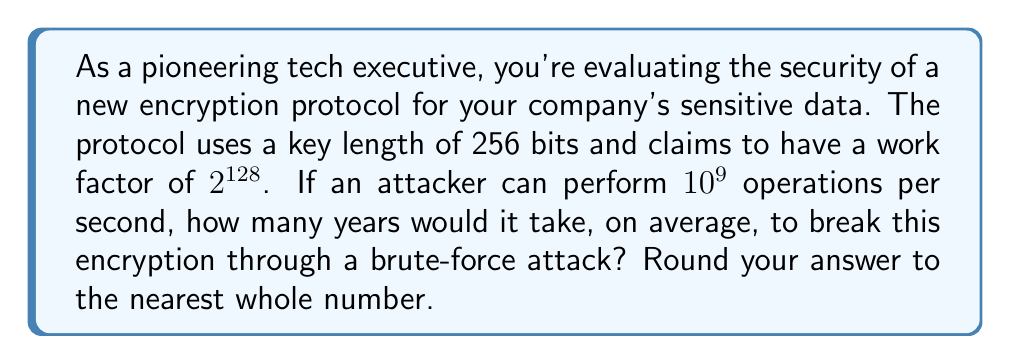Teach me how to tackle this problem. Let's approach this step-by-step:

1) First, we need to understand what the work factor means. A work factor of $2^{128}$ implies that, on average, an attacker would need to perform $2^{128}$ operations to break the encryption.

2) We're told the attacker can perform $10^9$ operations per second. Let's calculate how many operations they can perform in a year:

   Operations per year = $10^9 \times 60 \times 60 \times 24 \times 365.25$
                       = $31,557,600,000,000,000$ ≈ $3.1558 \times 10^{16}$

3) Now, let's set up the equation to find the number of years:

   $(\text{Years}) \times (3.1558 \times 10^{16}) = 2^{128}$

4) Solving for Years:

   $\text{Years} = \frac{2^{128}}{3.1558 \times 10^{16}}$

5) Let's calculate this:

   $2^{128} = 340,282,366,920,938,463,463,374,607,431,768,211,456$

   $\frac{340,282,366,920,938,463,463,374,607,431,768,211,456}{3.1558 \times 10^{16}}$
   $= 10,783,731,304,368,505,977$

6) Converting to years and rounding to the nearest whole number:

   10,783,731,304,368,505,977 years
Answer: 10,783,731,304,368,505,977 years 